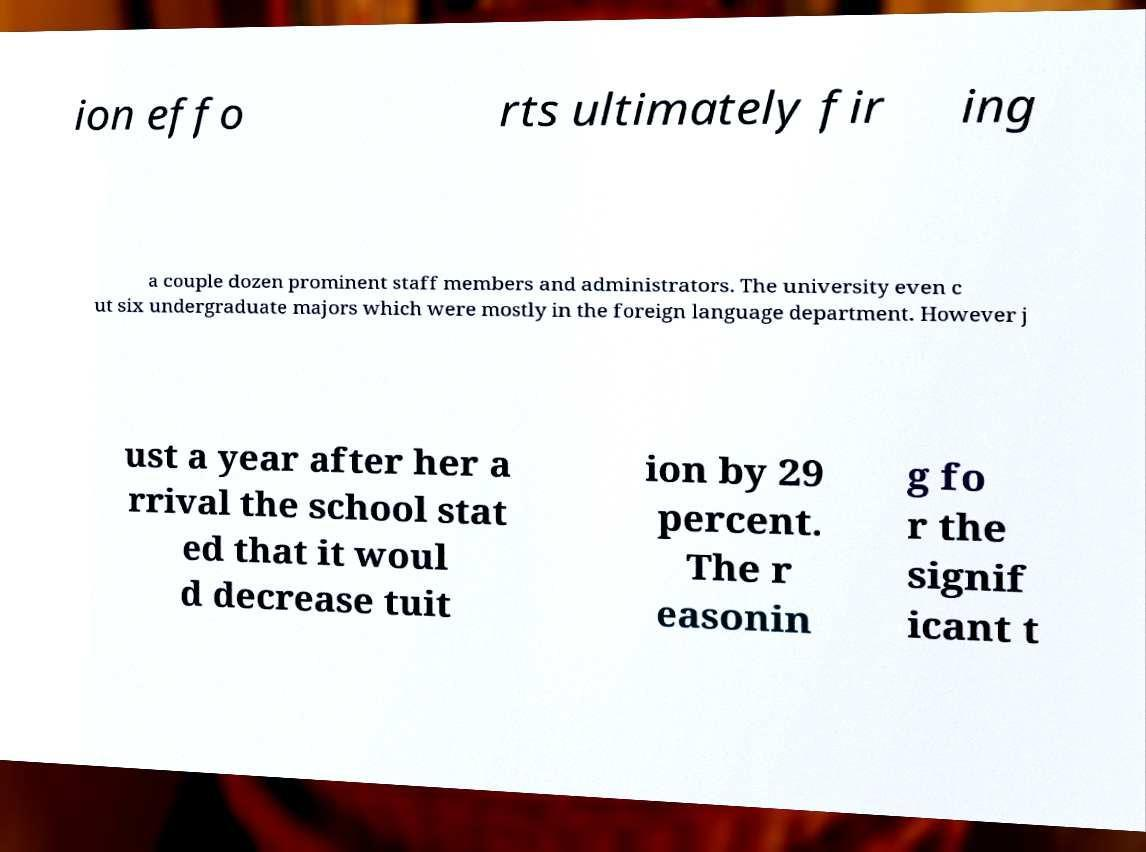For documentation purposes, I need the text within this image transcribed. Could you provide that? ion effo rts ultimately fir ing a couple dozen prominent staff members and administrators. The university even c ut six undergraduate majors which were mostly in the foreign language department. However j ust a year after her a rrival the school stat ed that it woul d decrease tuit ion by 29 percent. The r easonin g fo r the signif icant t 